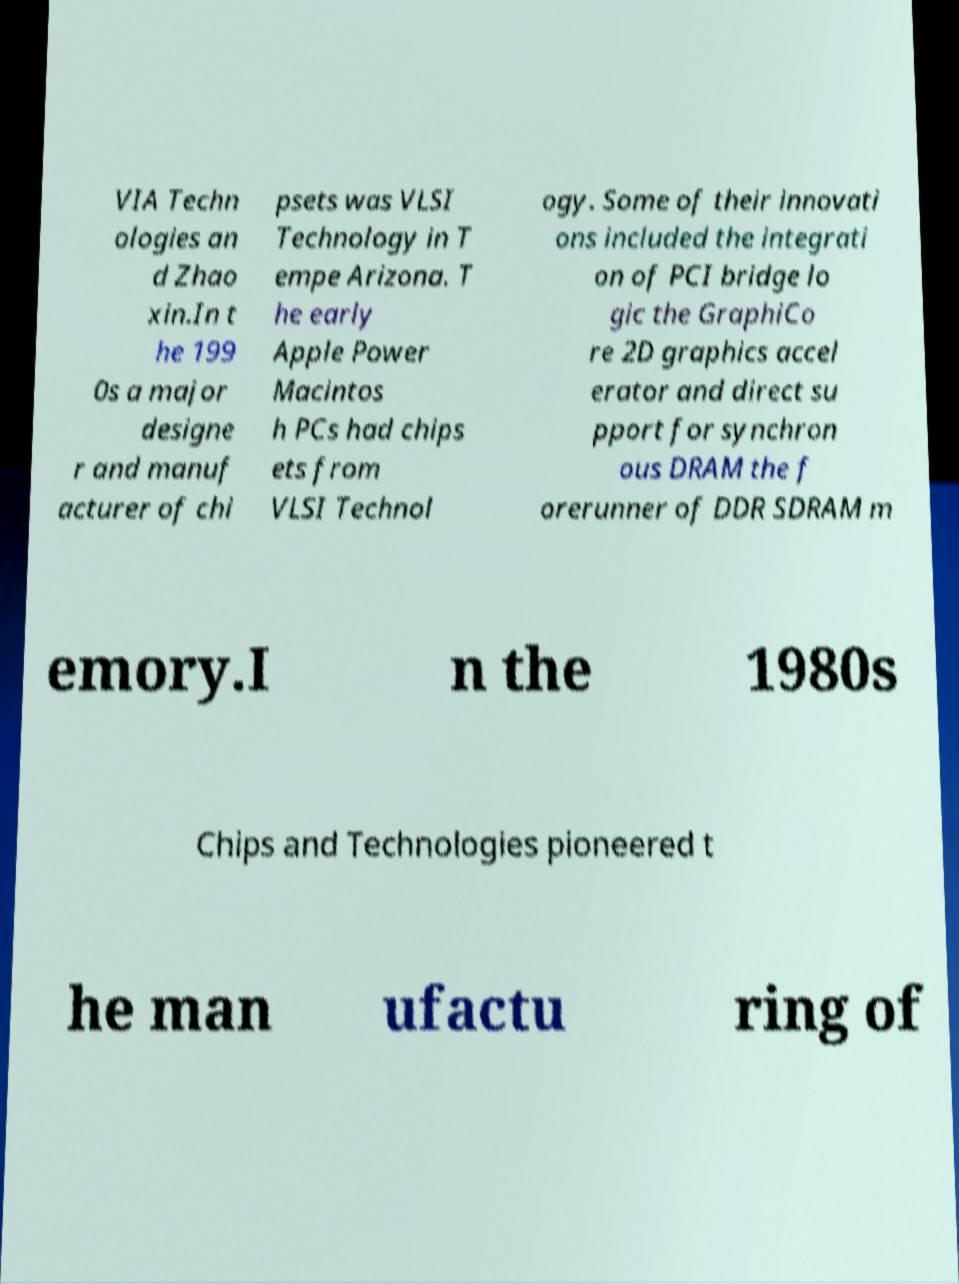Can you read and provide the text displayed in the image?This photo seems to have some interesting text. Can you extract and type it out for me? VIA Techn ologies an d Zhao xin.In t he 199 0s a major designe r and manuf acturer of chi psets was VLSI Technology in T empe Arizona. T he early Apple Power Macintos h PCs had chips ets from VLSI Technol ogy. Some of their innovati ons included the integrati on of PCI bridge lo gic the GraphiCo re 2D graphics accel erator and direct su pport for synchron ous DRAM the f orerunner of DDR SDRAM m emory.I n the 1980s Chips and Technologies pioneered t he man ufactu ring of 